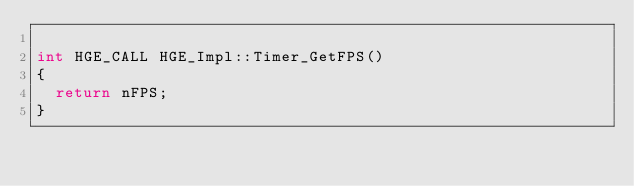Convert code to text. <code><loc_0><loc_0><loc_500><loc_500><_C++_>
int HGE_CALL HGE_Impl::Timer_GetFPS()
{
	return nFPS;
}

</code> 